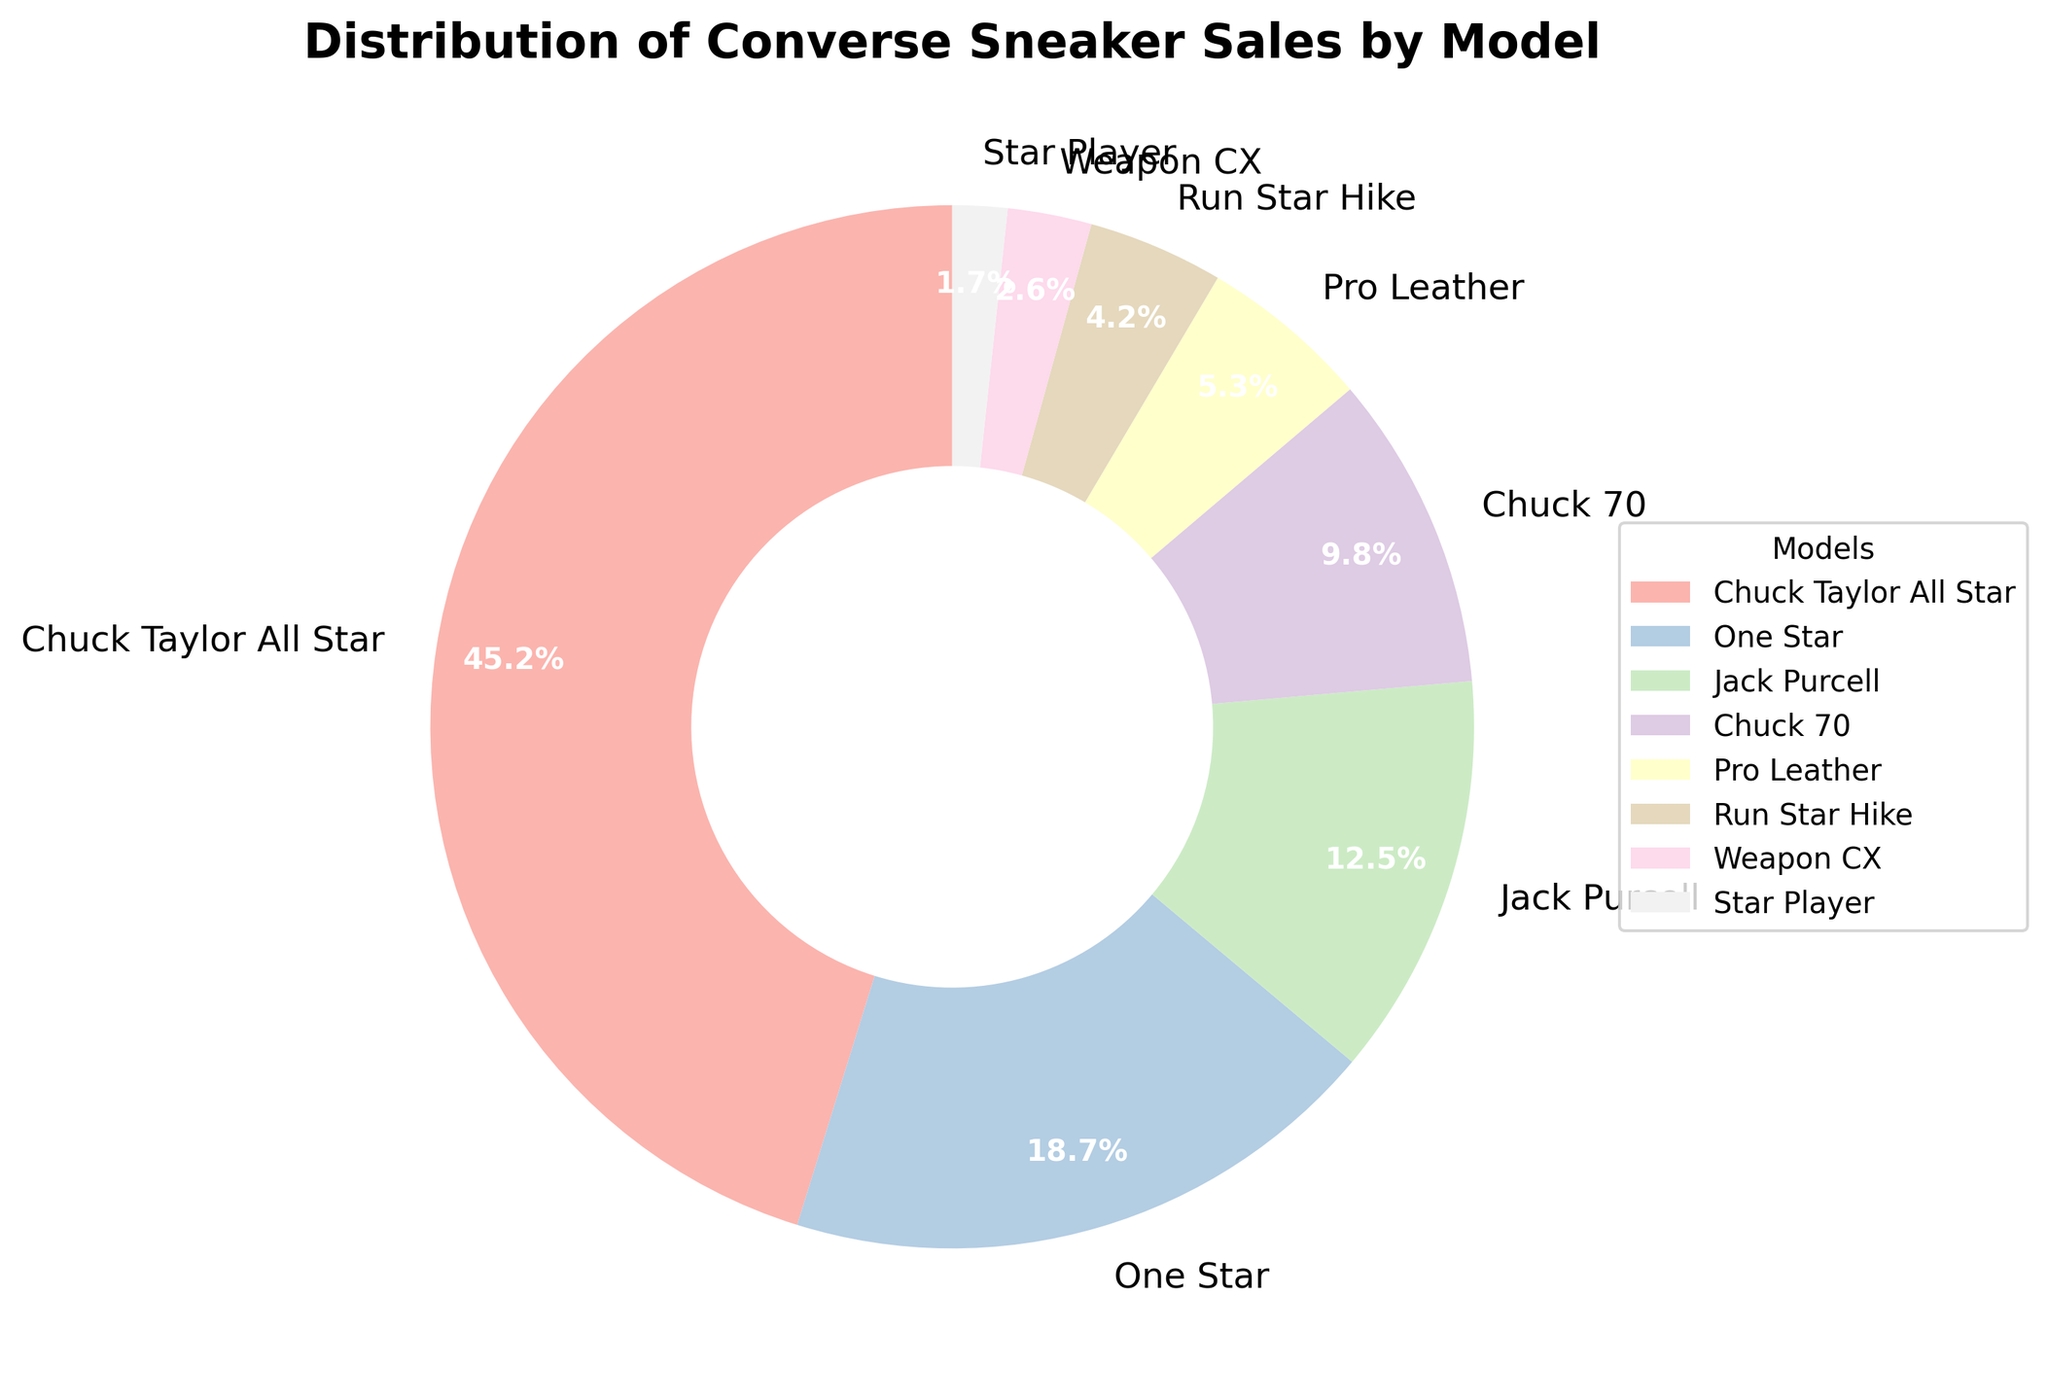What model has the highest percentage of sales? The chart shows different Converse sneaker models with their corresponding sales percentages. By inspecting the wedges, Chuck Taylor All Star has the largest portion.
Answer: Chuck Taylor All Star What is the absolute difference in sales percentage between the Chuck Taylor All Star and the One Star models? From the pie chart, Chuck Taylor All Star has 45.2% and One Star has 18.7%. The absolute difference is calculated as 45.2% - 18.7% = 26.5%.
Answer: 26.5% Which models have a sales percentage below 10%? By examining the labels in the pie chart, the models that have a percentage less than 10% are Chuck 70 (9.8%), Pro Leather (5.3%), Run Star Hike (4.2%), Weapon CX (2.6%), and Star Player (1.7%).
Answer: Chuck 70, Pro Leather, Run Star Hike, Weapon CX, Star Player Is the combined percentage of Chuck Taylor All Star and Run Star Hike more than 50%? Chuck Taylor All Star has 45.2% and Run Star Hike has 4.2%. The combined percentage is 45.2% + 4.2% = 49.4%, which is less than 50%.
Answer: No How many models have sales percentages greater than or equal to 5%? Checking each wedge in the pie chart, the models with 5% or more are Chuck Taylor All Star (45.2%), One Star (18.7%), Jack Purcell (12.5%), Chuck 70 (9.8%), and Pro Leather (5.3%). There are 5 such models.
Answer: 5 Which model has the second highest percentage of sales? Upon inspection, after Chuck Taylor All Star, One Star has the next largest wedge in the pie chart.
Answer: One Star What is the combined sales percentage of models with less than 5%? The pie chart indicates that models with less than 5% are Weapon CX (2.6%) and Star Player (1.7%). Their combined percentage is 2.6% + 1.7% = 4.3%.
Answer: 4.3% Describe the visual appearance of the wedges for Chuck Taylor All Star and why it stands out. Chuck Taylor All Star's wedge is the largest and occupies nearly half of the pie chart, making it visually prominent compared to the other wedges.
Answer: Largest wedge, visually prominent What is the total percentage of sales for the Jack Purcell and Chuck 70 models? By looking at the chart, Jack Purcell has 12.5% and Chuck 70 has 9.8%. Their total combined percentage is 12.5% + 9.8% = 22.3%.
Answer: 22.3% If a new model is added and takes 3% of the sales, what will be the new percentage for Chuck Taylor All Star assuming it absorbs the decrease evenly from all existing models? The new total percentage becomes 103%. The decrease distributed evenly would affect all percentages. Therefore, the new percentage for Chuck Taylor All Star would be reduced proportionally. The percentage for Chuck Taylor All Star would be (45.2/100)*97 = 43.844%.
Answer: 43.8% 